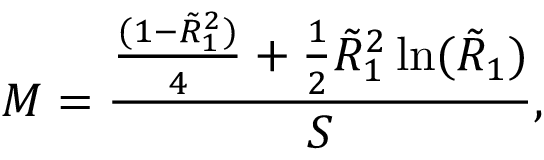<formula> <loc_0><loc_0><loc_500><loc_500>M = \frac { \frac { ( 1 - \tilde { R } _ { 1 } ^ { 2 } ) } { 4 } + \frac { 1 } { 2 } \tilde { R } _ { 1 } ^ { 2 } \ln ( \tilde { R } _ { 1 } ) } { S } ,</formula> 